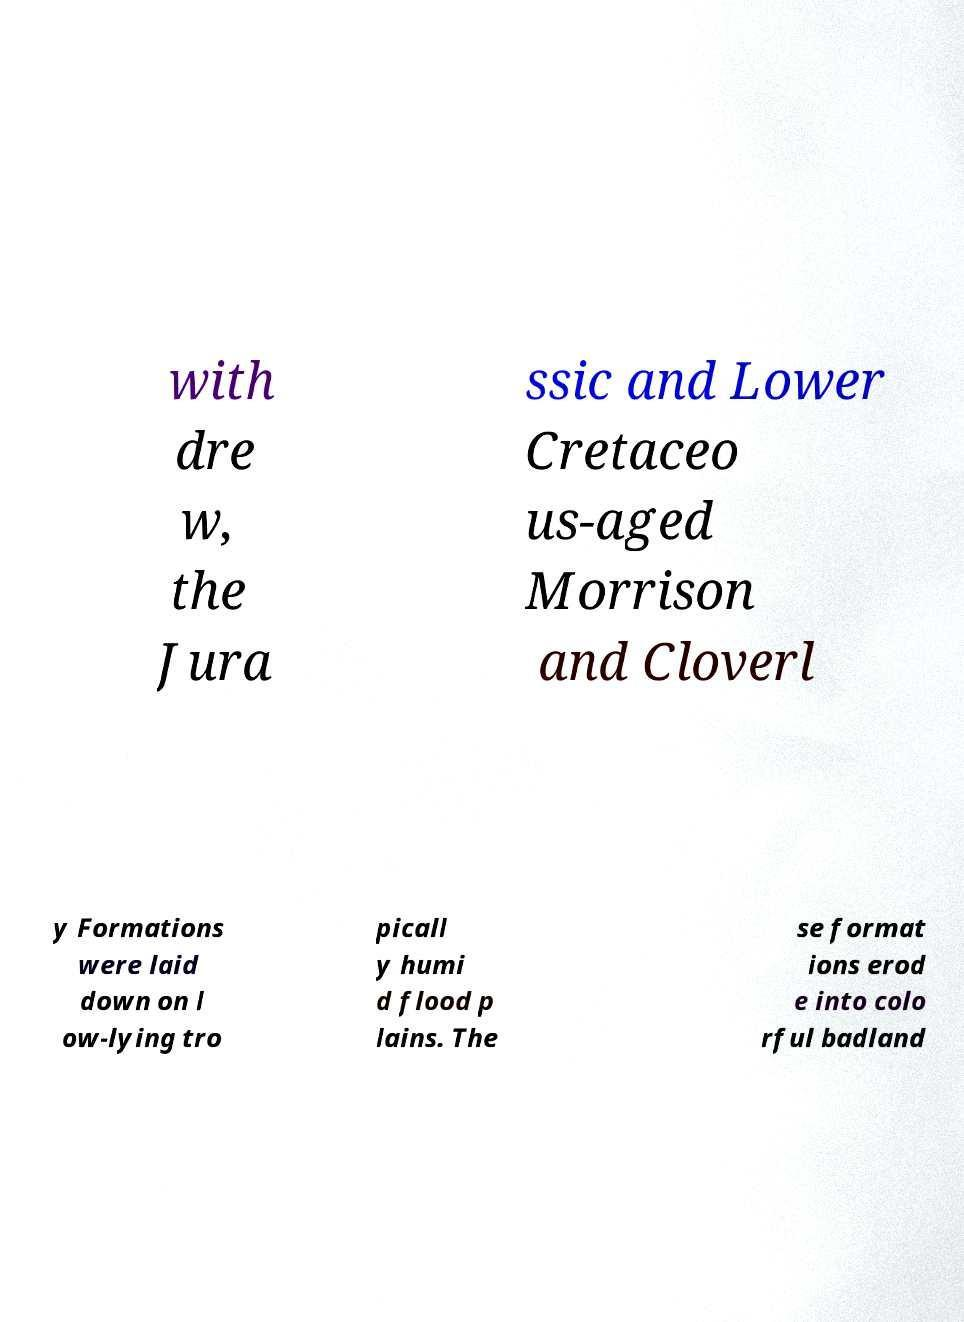Please read and relay the text visible in this image. What does it say? with dre w, the Jura ssic and Lower Cretaceo us-aged Morrison and Cloverl y Formations were laid down on l ow-lying tro picall y humi d flood p lains. The se format ions erod e into colo rful badland 